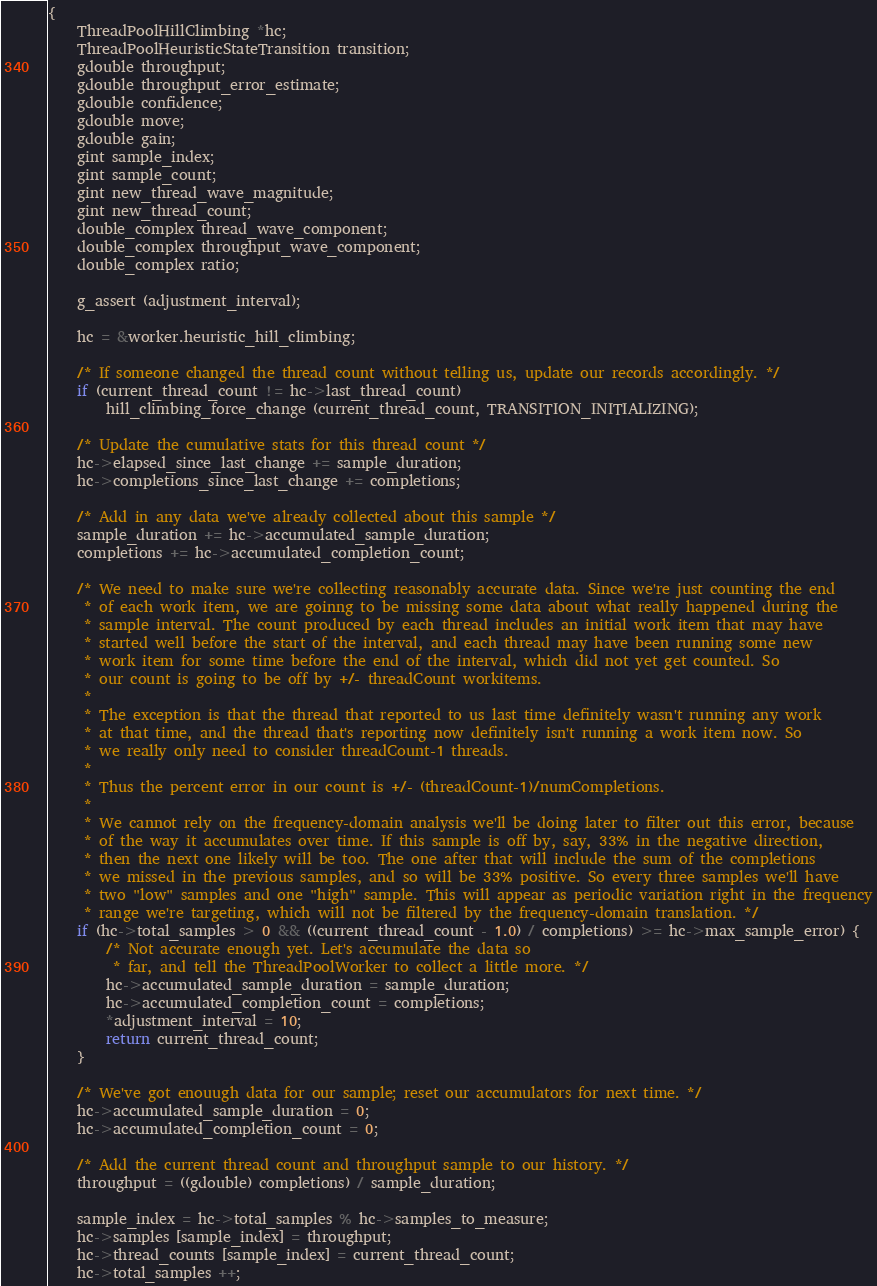Convert code to text. <code><loc_0><loc_0><loc_500><loc_500><_C_>{
	ThreadPoolHillClimbing *hc;
	ThreadPoolHeuristicStateTransition transition;
	gdouble throughput;
	gdouble throughput_error_estimate;
	gdouble confidence;
	gdouble move;
	gdouble gain;
	gint sample_index;
	gint sample_count;
	gint new_thread_wave_magnitude;
	gint new_thread_count;
	double_complex thread_wave_component;
	double_complex throughput_wave_component;
	double_complex ratio;

	g_assert (adjustment_interval);

	hc = &worker.heuristic_hill_climbing;

	/* If someone changed the thread count without telling us, update our records accordingly. */
	if (current_thread_count != hc->last_thread_count)
		hill_climbing_force_change (current_thread_count, TRANSITION_INITIALIZING);

	/* Update the cumulative stats for this thread count */
	hc->elapsed_since_last_change += sample_duration;
	hc->completions_since_last_change += completions;

	/* Add in any data we've already collected about this sample */
	sample_duration += hc->accumulated_sample_duration;
	completions += hc->accumulated_completion_count;

	/* We need to make sure we're collecting reasonably accurate data. Since we're just counting the end
	 * of each work item, we are goinng to be missing some data about what really happened during the
	 * sample interval. The count produced by each thread includes an initial work item that may have
	 * started well before the start of the interval, and each thread may have been running some new
	 * work item for some time before the end of the interval, which did not yet get counted. So
	 * our count is going to be off by +/- threadCount workitems.
	 *
	 * The exception is that the thread that reported to us last time definitely wasn't running any work
	 * at that time, and the thread that's reporting now definitely isn't running a work item now. So
	 * we really only need to consider threadCount-1 threads.
	 *
	 * Thus the percent error in our count is +/- (threadCount-1)/numCompletions.
	 *
	 * We cannot rely on the frequency-domain analysis we'll be doing later to filter out this error, because
	 * of the way it accumulates over time. If this sample is off by, say, 33% in the negative direction,
	 * then the next one likely will be too. The one after that will include the sum of the completions
	 * we missed in the previous samples, and so will be 33% positive. So every three samples we'll have
	 * two "low" samples and one "high" sample. This will appear as periodic variation right in the frequency
	 * range we're targeting, which will not be filtered by the frequency-domain translation. */
	if (hc->total_samples > 0 && ((current_thread_count - 1.0) / completions) >= hc->max_sample_error) {
		/* Not accurate enough yet. Let's accumulate the data so
		 * far, and tell the ThreadPoolWorker to collect a little more. */
		hc->accumulated_sample_duration = sample_duration;
		hc->accumulated_completion_count = completions;
		*adjustment_interval = 10;
		return current_thread_count;
	}

	/* We've got enouugh data for our sample; reset our accumulators for next time. */
	hc->accumulated_sample_duration = 0;
	hc->accumulated_completion_count = 0;

	/* Add the current thread count and throughput sample to our history. */
	throughput = ((gdouble) completions) / sample_duration;

	sample_index = hc->total_samples % hc->samples_to_measure;
	hc->samples [sample_index] = throughput;
	hc->thread_counts [sample_index] = current_thread_count;
	hc->total_samples ++;
</code> 